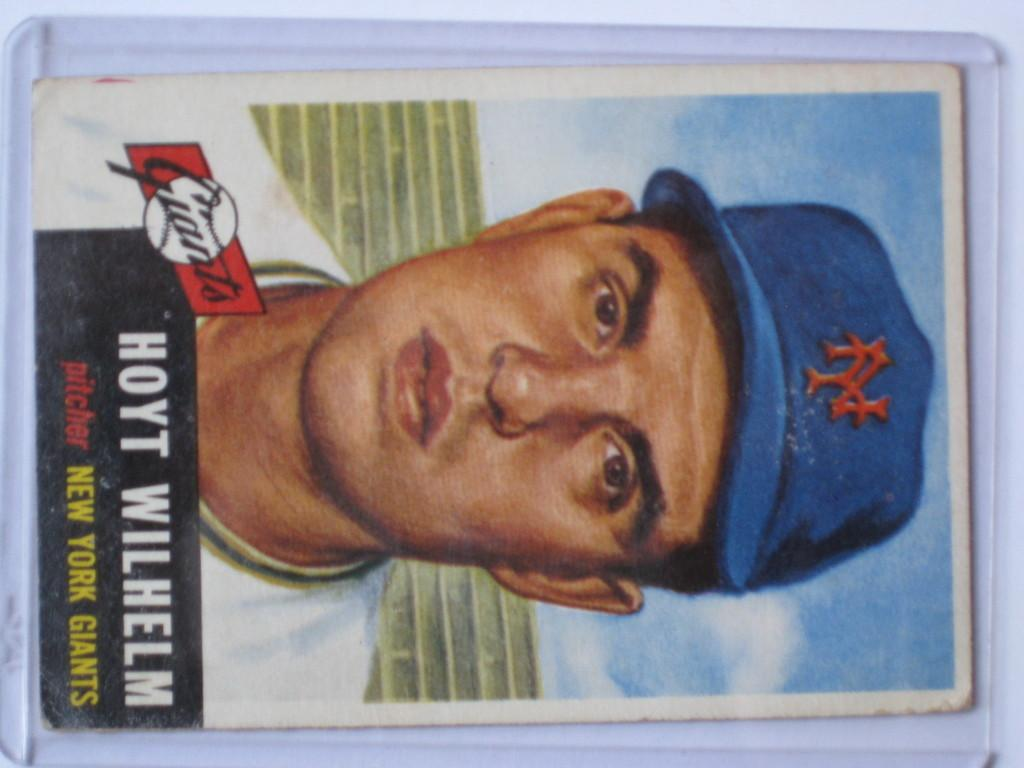What is the main subject of the image? The main subject of the image is a person's face. What accessory is the person wearing in the image? The person is wearing a hat in the image. Is there any additional information or imagery in the image? Yes, there is text or an image in the left bottom corner of the image. What type of land can be seen in the middle of the image? There is no land present in the image; it features a person's face and a hat. How many needles are visible in the image? There are no needles present in the image. 